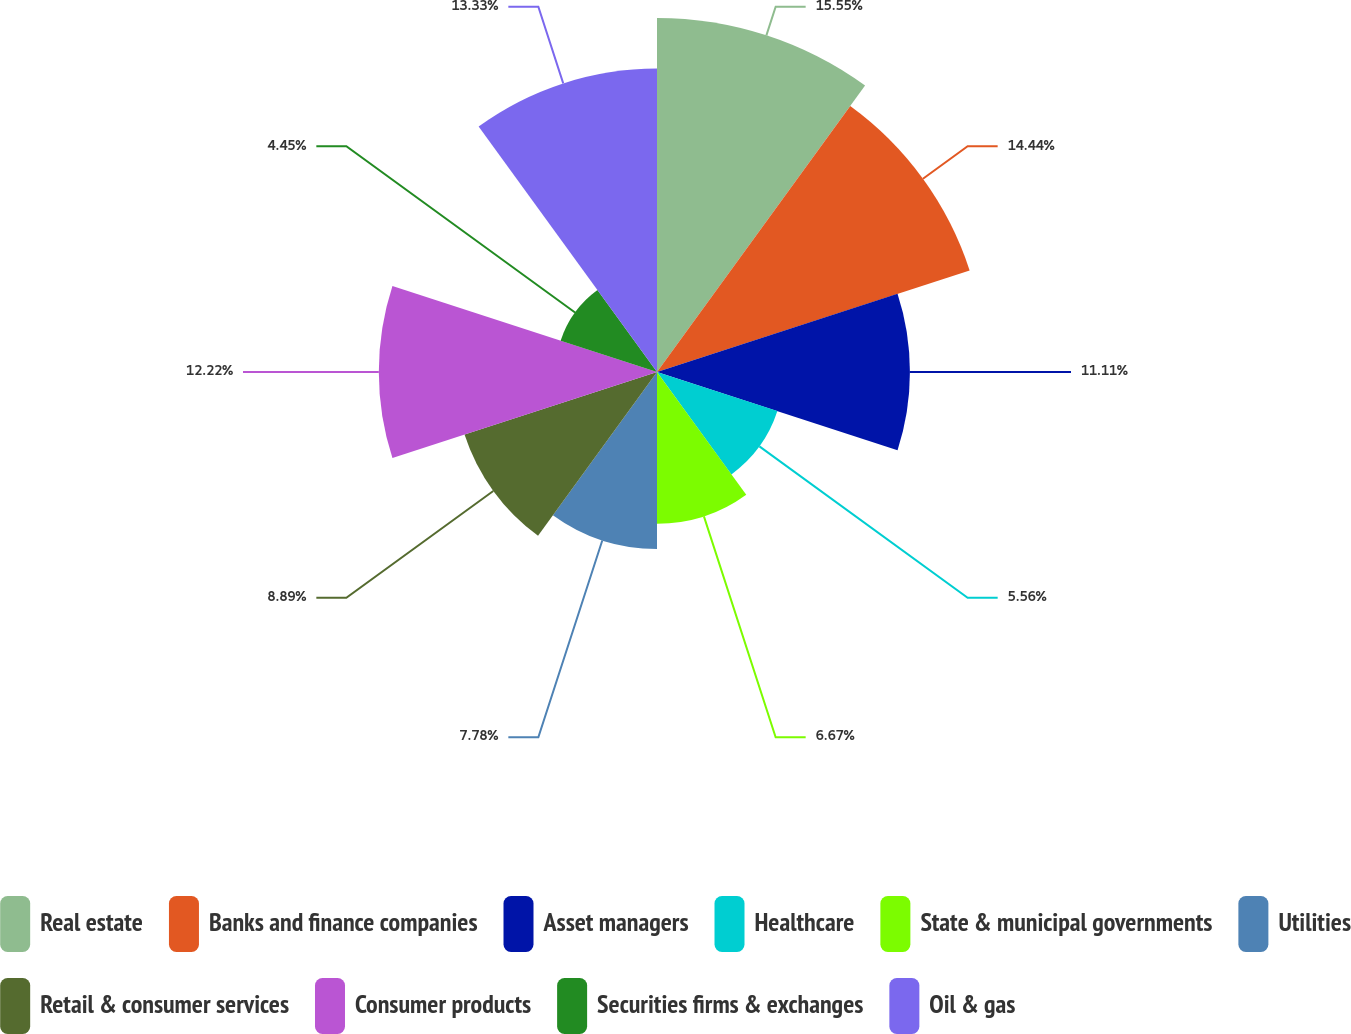<chart> <loc_0><loc_0><loc_500><loc_500><pie_chart><fcel>Real estate<fcel>Banks and finance companies<fcel>Asset managers<fcel>Healthcare<fcel>State & municipal governments<fcel>Utilities<fcel>Retail & consumer services<fcel>Consumer products<fcel>Securities firms & exchanges<fcel>Oil & gas<nl><fcel>15.55%<fcel>14.44%<fcel>11.11%<fcel>5.56%<fcel>6.67%<fcel>7.78%<fcel>8.89%<fcel>12.22%<fcel>4.45%<fcel>13.33%<nl></chart> 